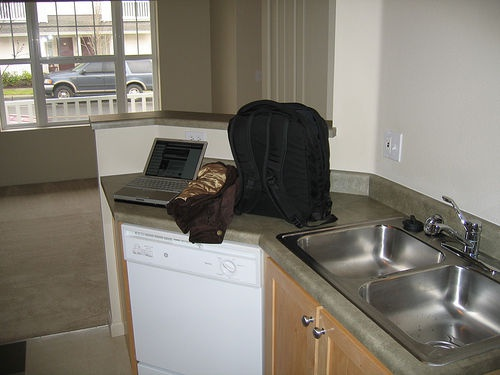Describe the objects in this image and their specific colors. I can see sink in black, gray, and darkgray tones, backpack in black and gray tones, laptop in black and gray tones, and car in black, darkgray, gray, lightgray, and beige tones in this image. 